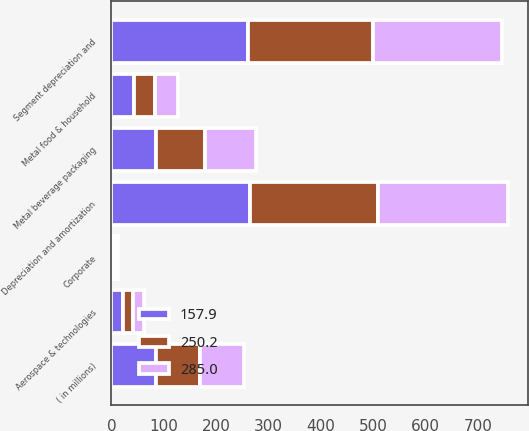<chart> <loc_0><loc_0><loc_500><loc_500><stacked_bar_chart><ecel><fcel>( in millions)<fcel>Metal beverage packaging<fcel>Metal food & household<fcel>Aerospace & technologies<fcel>Segment depreciation and<fcel>Corporate<fcel>Depreciation and amortization<nl><fcel>157.9<fcel>84.5<fcel>84.7<fcel>42.5<fcel>21.7<fcel>261.6<fcel>3.9<fcel>265.5<nl><fcel>250.2<fcel>84.5<fcel>93.7<fcel>41.3<fcel>20.2<fcel>238.7<fcel>4.4<fcel>243.1<nl><fcel>285<fcel>84.5<fcel>97.2<fcel>43.8<fcel>19.5<fcel>245<fcel>4.9<fcel>249.9<nl></chart> 